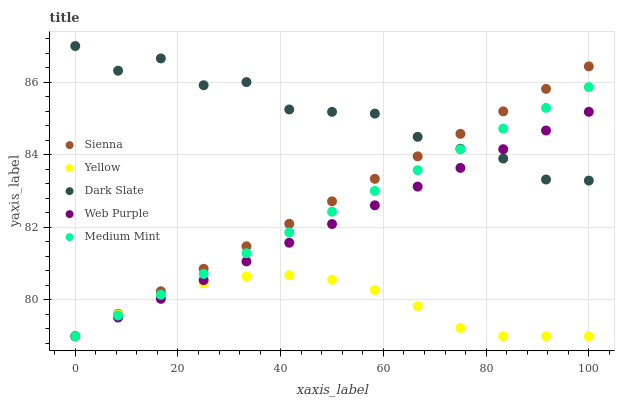Does Yellow have the minimum area under the curve?
Answer yes or no. Yes. Does Dark Slate have the maximum area under the curve?
Answer yes or no. Yes. Does Web Purple have the minimum area under the curve?
Answer yes or no. No. Does Web Purple have the maximum area under the curve?
Answer yes or no. No. Is Sienna the smoothest?
Answer yes or no. Yes. Is Dark Slate the roughest?
Answer yes or no. Yes. Is Web Purple the smoothest?
Answer yes or no. No. Is Web Purple the roughest?
Answer yes or no. No. Does Sienna have the lowest value?
Answer yes or no. Yes. Does Dark Slate have the lowest value?
Answer yes or no. No. Does Dark Slate have the highest value?
Answer yes or no. Yes. Does Web Purple have the highest value?
Answer yes or no. No. Is Yellow less than Dark Slate?
Answer yes or no. Yes. Is Dark Slate greater than Yellow?
Answer yes or no. Yes. Does Web Purple intersect Yellow?
Answer yes or no. Yes. Is Web Purple less than Yellow?
Answer yes or no. No. Is Web Purple greater than Yellow?
Answer yes or no. No. Does Yellow intersect Dark Slate?
Answer yes or no. No. 